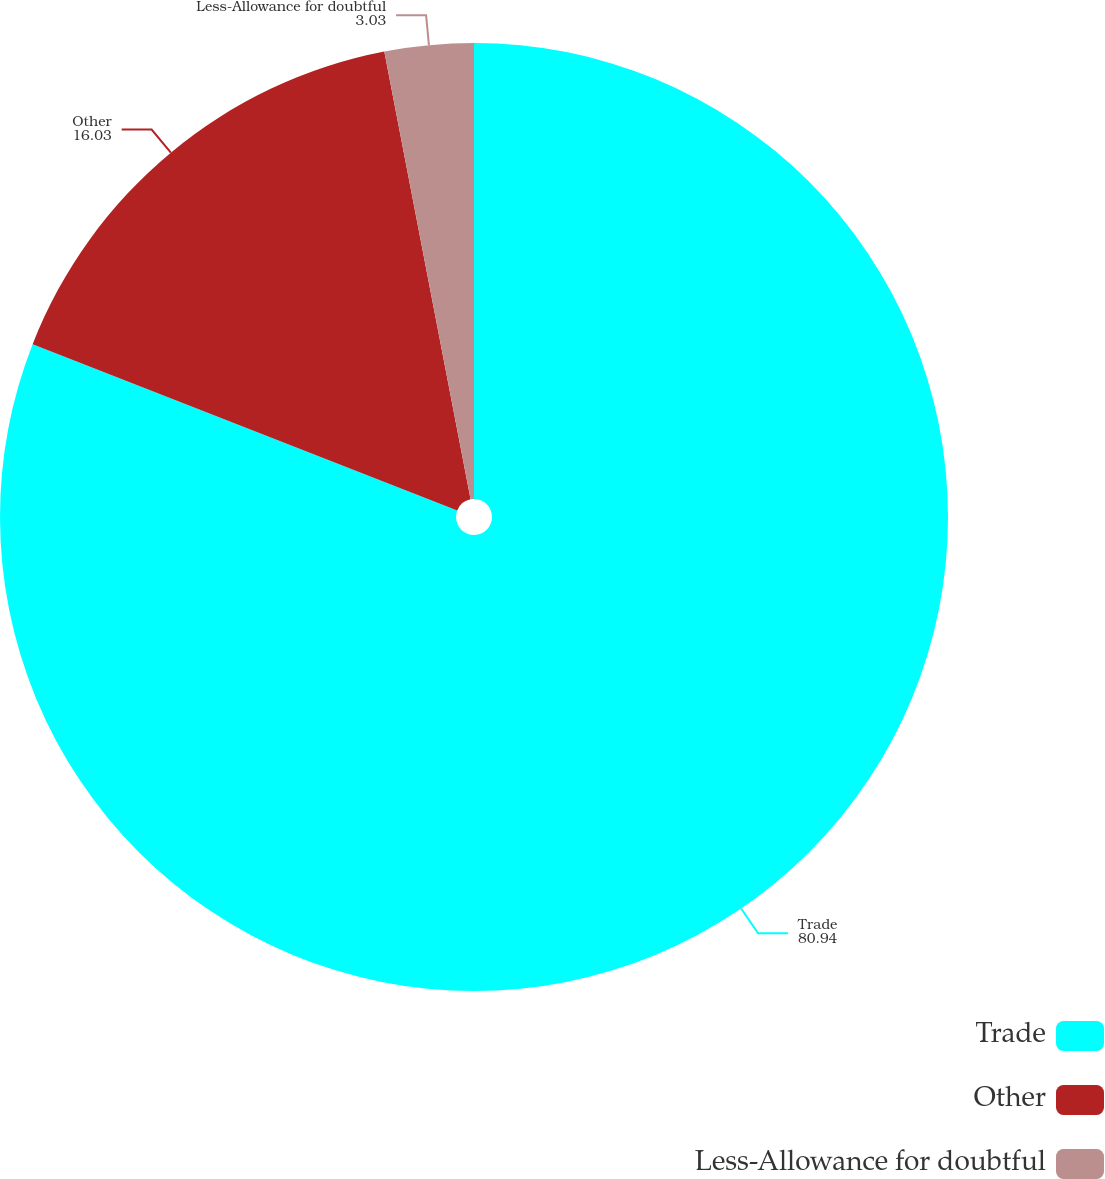Convert chart to OTSL. <chart><loc_0><loc_0><loc_500><loc_500><pie_chart><fcel>Trade<fcel>Other<fcel>Less-Allowance for doubtful<nl><fcel>80.94%<fcel>16.03%<fcel>3.03%<nl></chart> 